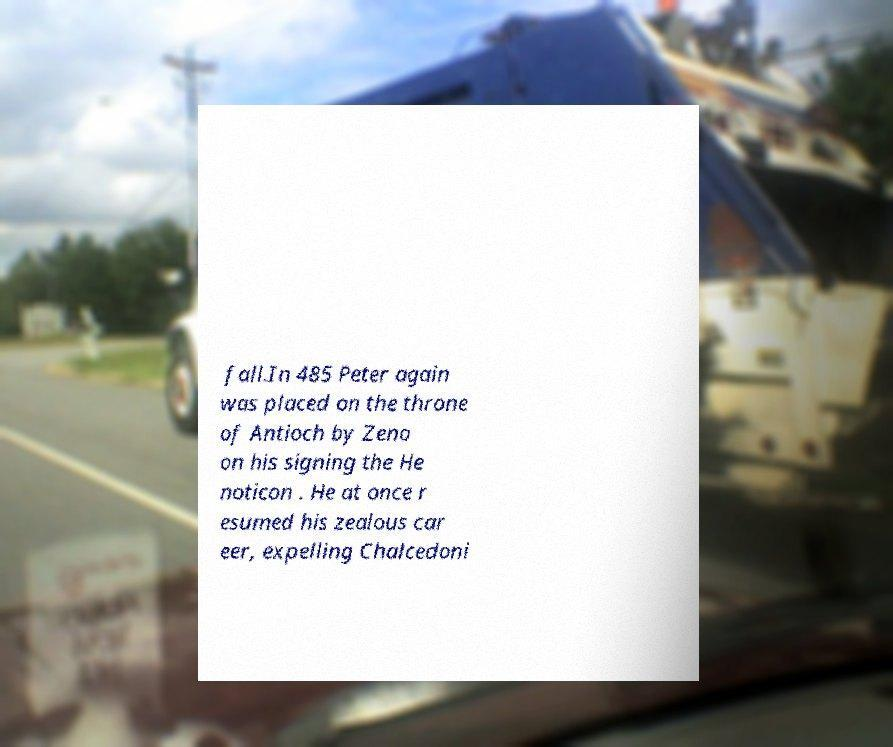What messages or text are displayed in this image? I need them in a readable, typed format. fall.In 485 Peter again was placed on the throne of Antioch by Zeno on his signing the He noticon . He at once r esumed his zealous car eer, expelling Chalcedoni 